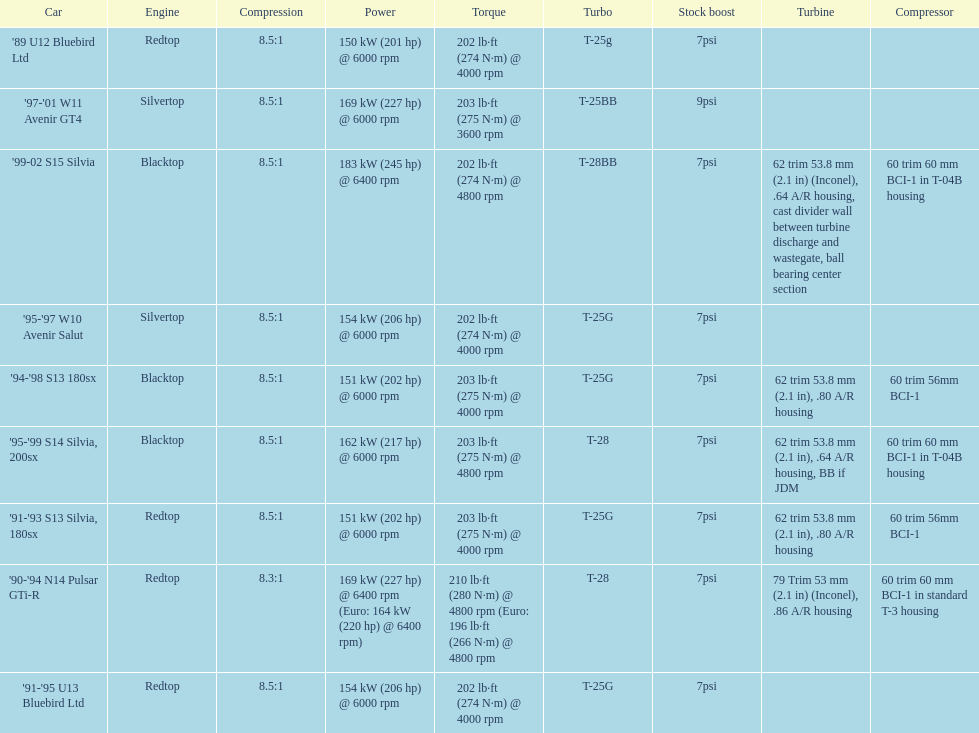Which engines are the same as the first entry ('89 u12 bluebird ltd)? '91-'95 U13 Bluebird Ltd, '90-'94 N14 Pulsar GTi-R, '91-'93 S13 Silvia, 180sx. 